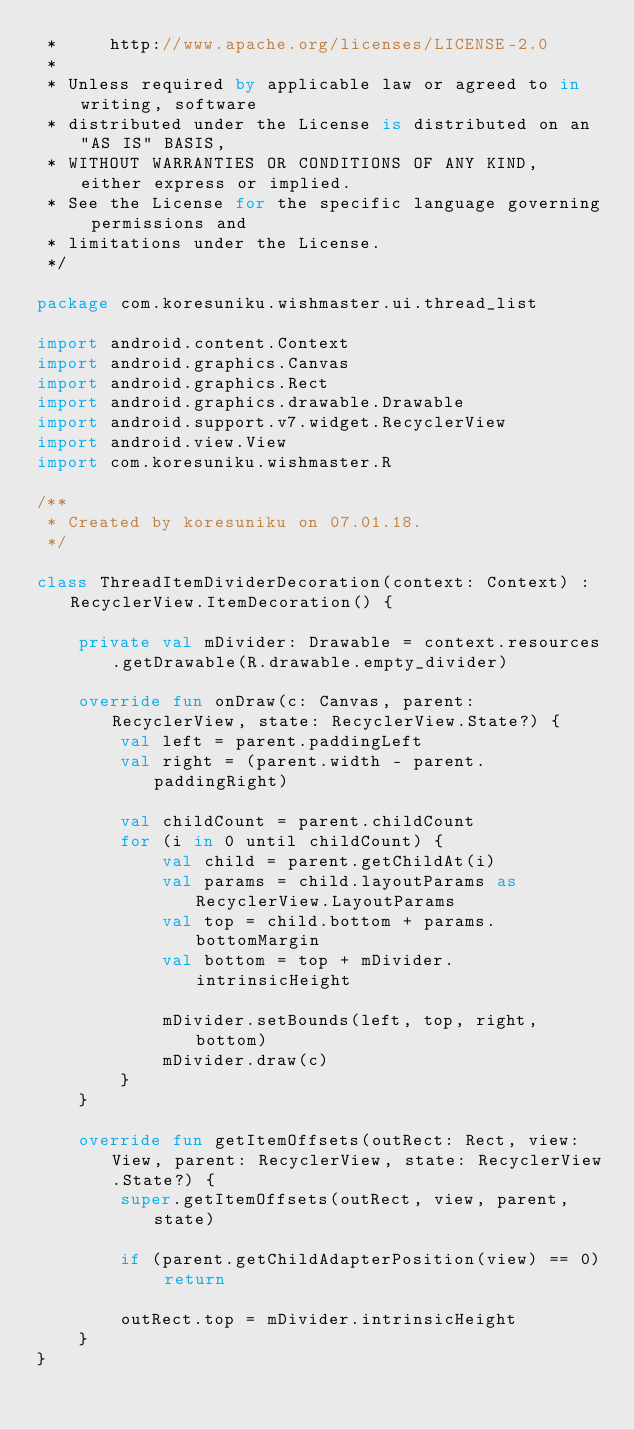Convert code to text. <code><loc_0><loc_0><loc_500><loc_500><_Kotlin_> *     http://www.apache.org/licenses/LICENSE-2.0
 *
 * Unless required by applicable law or agreed to in writing, software
 * distributed under the License is distributed on an "AS IS" BASIS,
 * WITHOUT WARRANTIES OR CONDITIONS OF ANY KIND, either express or implied.
 * See the License for the specific language governing permissions and
 * limitations under the License.
 */

package com.koresuniku.wishmaster.ui.thread_list

import android.content.Context
import android.graphics.Canvas
import android.graphics.Rect
import android.graphics.drawable.Drawable
import android.support.v7.widget.RecyclerView
import android.view.View
import com.koresuniku.wishmaster.R

/**
 * Created by koresuniku on 07.01.18.
 */

class ThreadItemDividerDecoration(context: Context) : RecyclerView.ItemDecoration() {

    private val mDivider: Drawable = context.resources.getDrawable(R.drawable.empty_divider)

    override fun onDraw(c: Canvas, parent: RecyclerView, state: RecyclerView.State?) {
        val left = parent.paddingLeft
        val right = (parent.width - parent.paddingRight)

        val childCount = parent.childCount
        for (i in 0 until childCount) {
            val child = parent.getChildAt(i)
            val params = child.layoutParams as RecyclerView.LayoutParams
            val top = child.bottom + params.bottomMargin
            val bottom = top + mDivider.intrinsicHeight

            mDivider.setBounds(left, top, right, bottom)
            mDivider.draw(c)
        }
    }

    override fun getItemOffsets(outRect: Rect, view: View, parent: RecyclerView, state: RecyclerView.State?) {
        super.getItemOffsets(outRect, view, parent, state)

        if (parent.getChildAdapterPosition(view) == 0) return

        outRect.top = mDivider.intrinsicHeight
    }
}</code> 